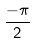<formula> <loc_0><loc_0><loc_500><loc_500>\frac { - \pi } { 2 }</formula> 